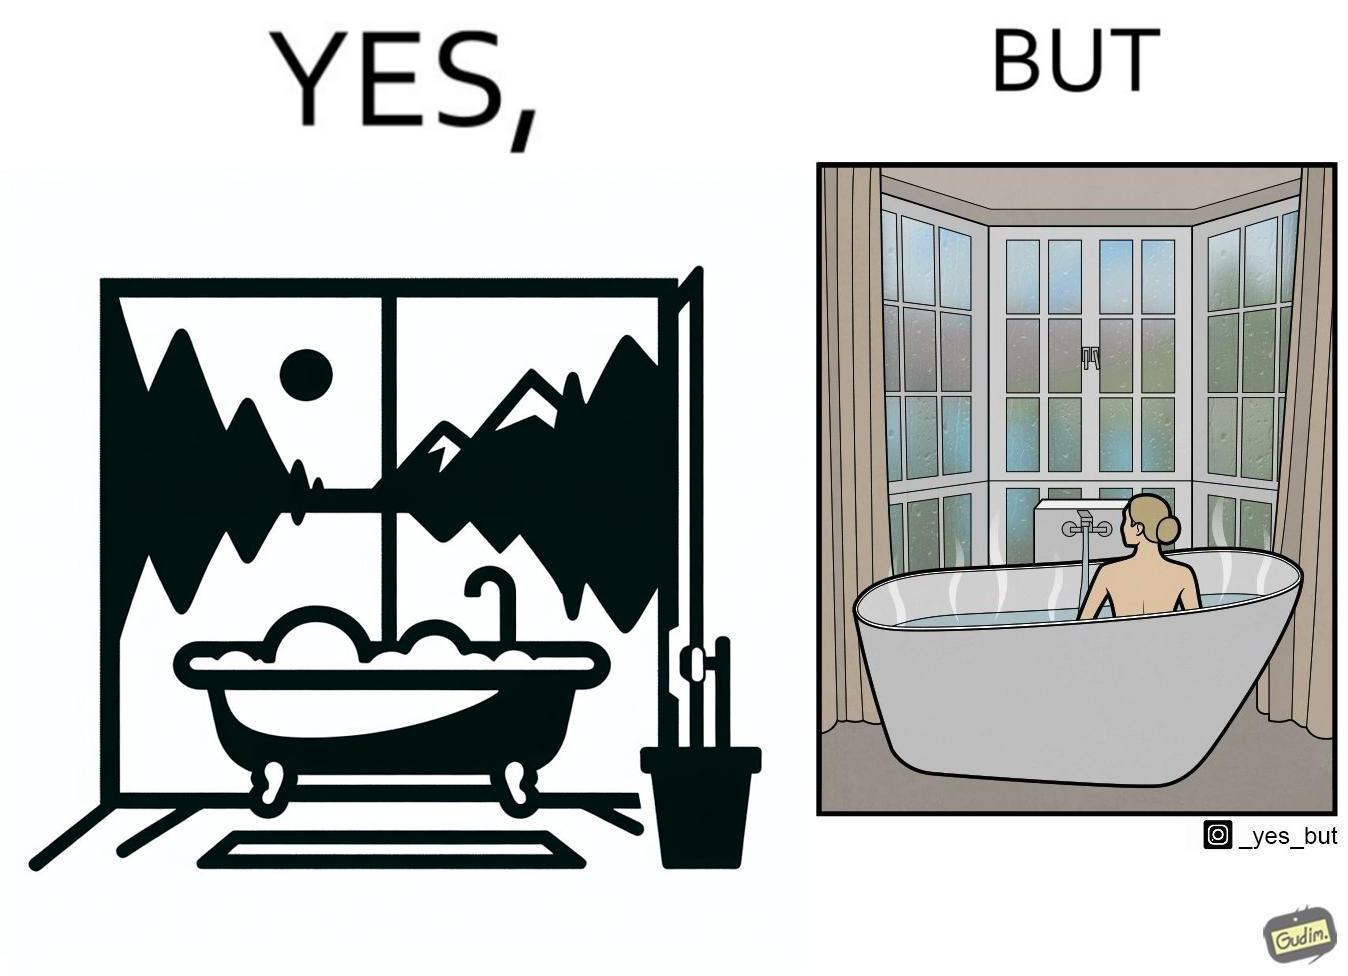Is there satirical content in this image? Yes, this image is satirical. 